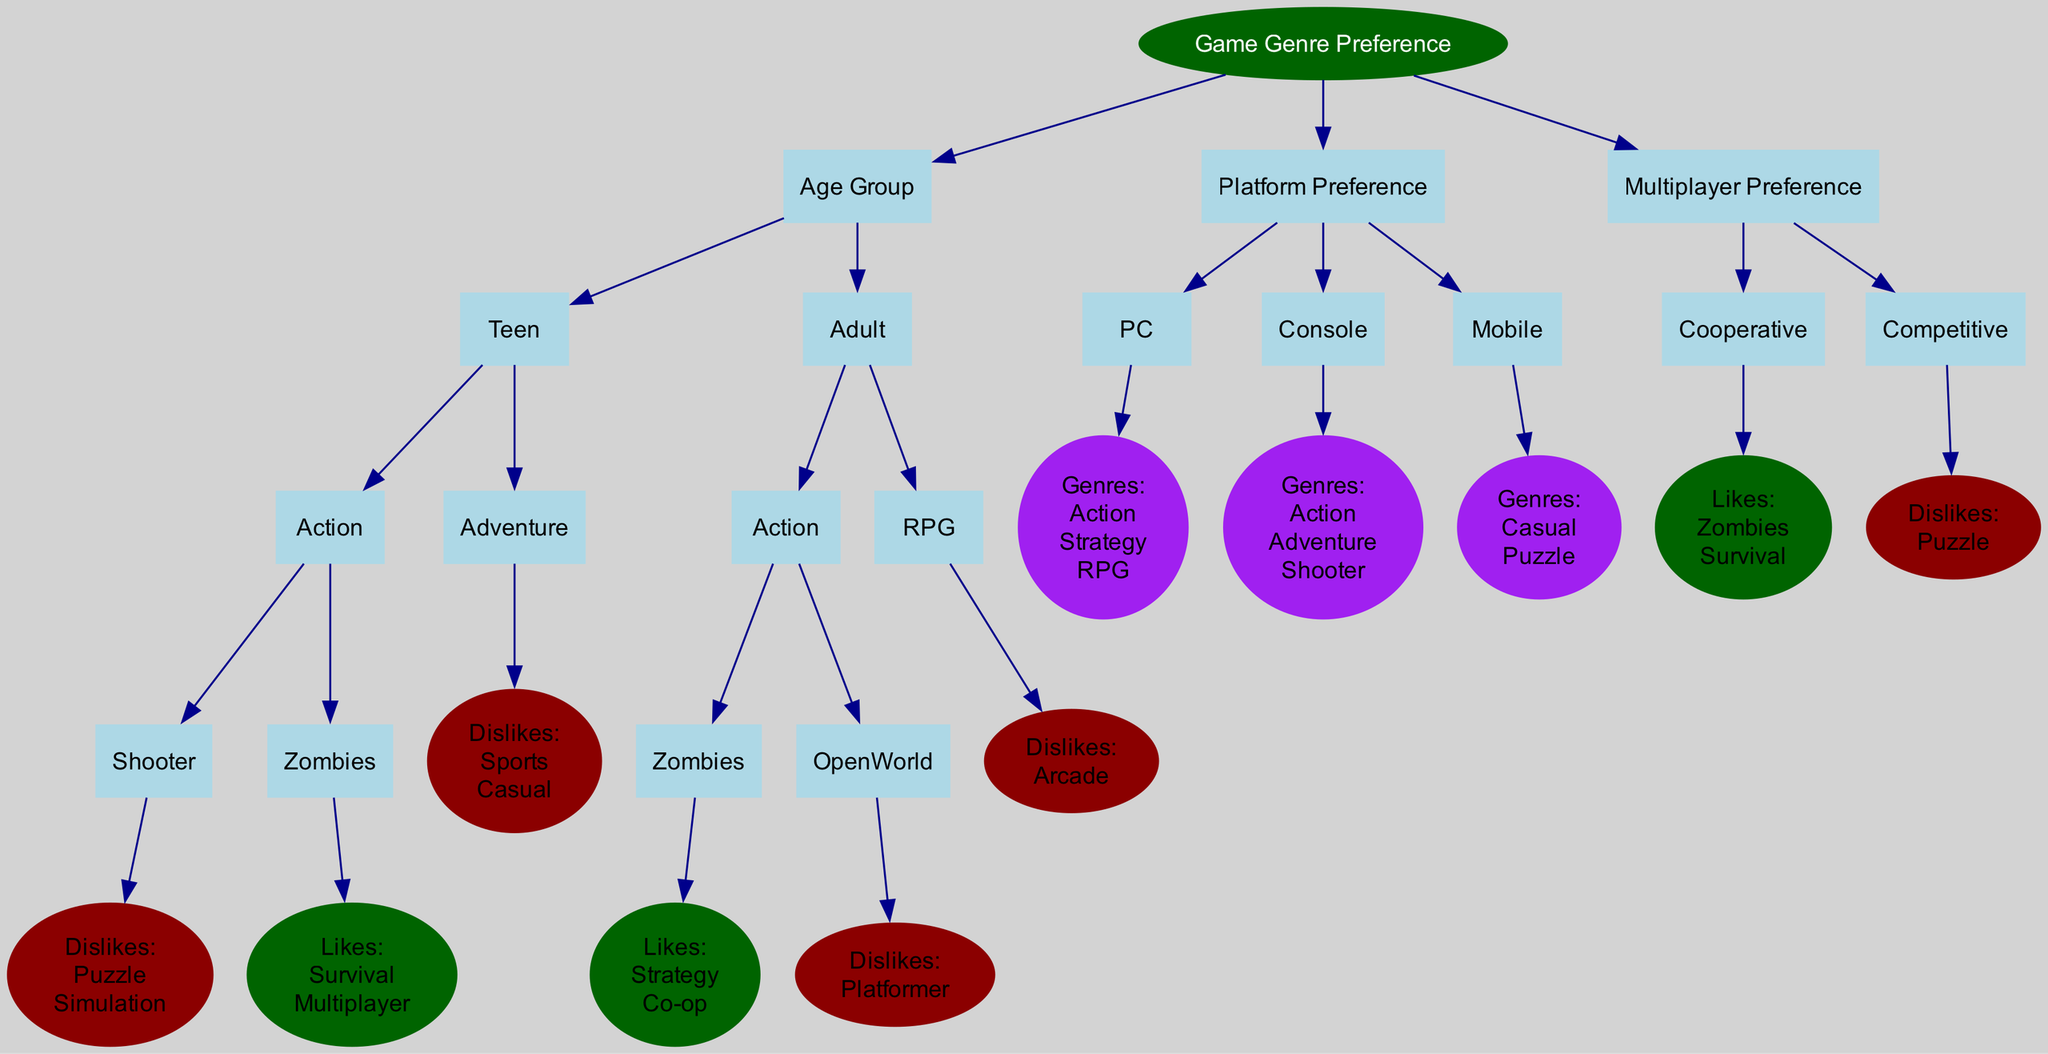What are the two age groups represented in the diagram? The diagram has two nodes under the "Age Group" section: "Teen" and "Adult." Thus, the represented age groups are Teen and Adult.
Answer: Teen, Adult Which genre does the 'Teen' age group like under 'Action'? In the diagram, under "Teen" and "Action," the sub-genre "Zombies" is listed with the likes of "Survival" and "Multiplayer." Therefore, "Zombies" is the liked genre.
Answer: Zombies How many sub-genres are listed for the 'Adult' age group's 'Action' category? The 'Adult' age group has two sub-genres under 'Action': "Zombies" and "OpenWorld." Therefore, the number of sub-genres is two.
Answer: 2 What genre is listed under 'PC' platform preference? The diagram shows three genres under the "PC" platform including "Action," "Strategy," and "RPG." Therefore, one of the genres listed is "Action."
Answer: Action What does the 'Cooperative' multiplayer preference like? In the diagram, under the "Cooperative" multiplayer preference, it lists "Likes: Zombies, Survival." Therefore, it likes Zombies and Survival.
Answer: Zombies, Survival Are there any dislikes mentioned for the 'Adult' age group under 'RPG'? The diagram states that the 'Adult' age group dislikes "Arcade" under the 'RPG' category. Therefore, there is a dislike mentioned.
Answer: Arcade Count the total number of genres listed under the 'Console' platform preference. Under the "Console" platform section in the diagram, the genres include "Action," "Adventure," and "Shooter," which totals three genres.
Answer: 3 Which genre is NOT liked by the 'Competitive' multiplayer preference? The diagram explicitly states that the 'Competitive' multiplayer preference "Dislikes: Puzzle." Therefore, the disallowed genre is "Puzzle."
Answer: Puzzle Which sub-genre under 'Teen' and 'Adventure' has a dislike listed? In the diagram, the "Adventure" genre under "Teen" states "Dislikes: Sports, Casual." Therefore, there are dislikes listed: Sports and Casual.
Answer: Sports, Casual 